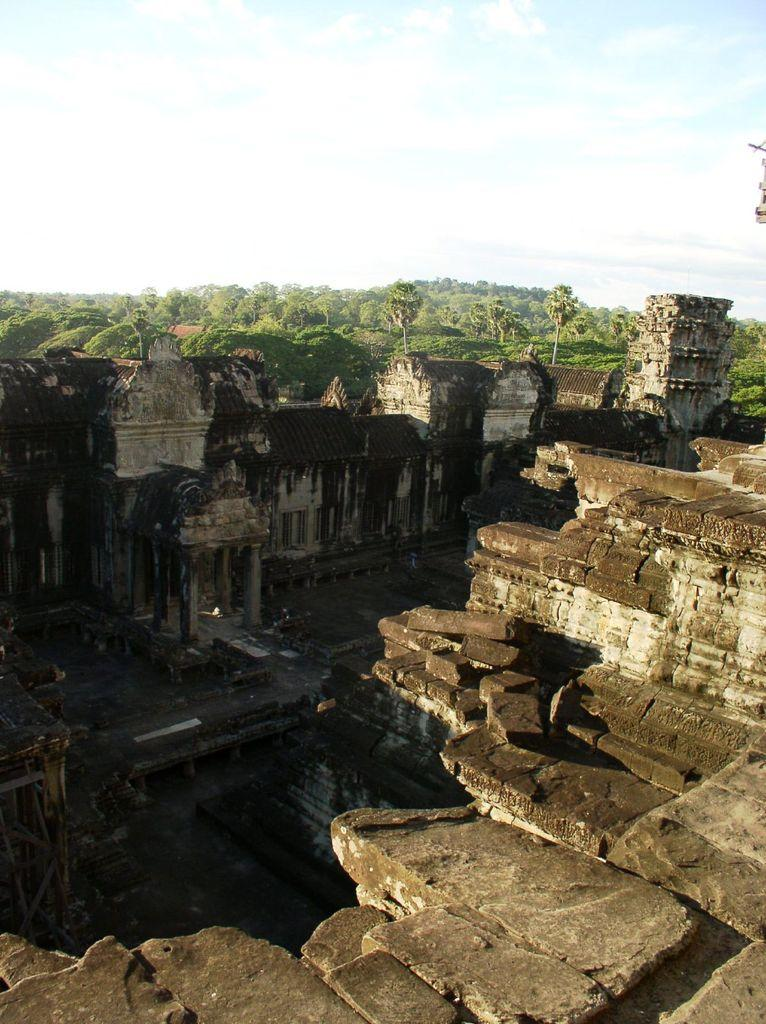What is the main structure featured in the image? There is a temple called Angkor Wat in the image. What can be seen in the background of the image? There are trees in the background of the image. What is the condition of the sky in the image? The sky is clear and visible in the background of the image. What type of brass instrument can be heard playing in the image? There is no brass instrument or sound present in the image, as it is a still photograph of a temple. 